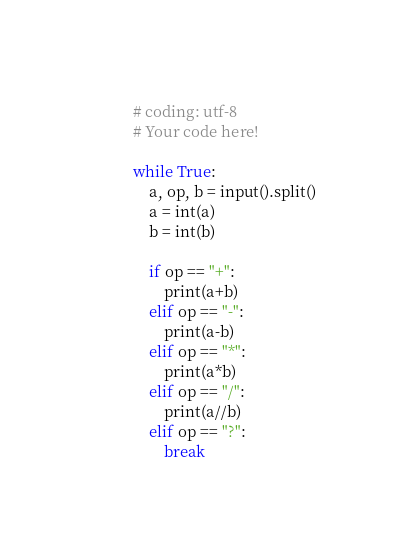<code> <loc_0><loc_0><loc_500><loc_500><_Python_># coding: utf-8
# Your code here!

while True:
    a, op, b = input().split()
    a = int(a)
    b = int(b)

    if op == "+":
        print(a+b)
    elif op == "-":
        print(a-b)
    elif op == "*":
        print(a*b)
    elif op == "/":
        print(a//b)
    elif op == "?":
        break
</code> 